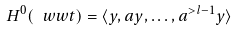<formula> <loc_0><loc_0><loc_500><loc_500>H ^ { 0 } ( \ w w t ) = \langle y , a y , \dots , a ^ { > l - 1 } y \rangle</formula> 